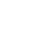Convert code to text. <code><loc_0><loc_0><loc_500><loc_500><_C++_>
</code> 